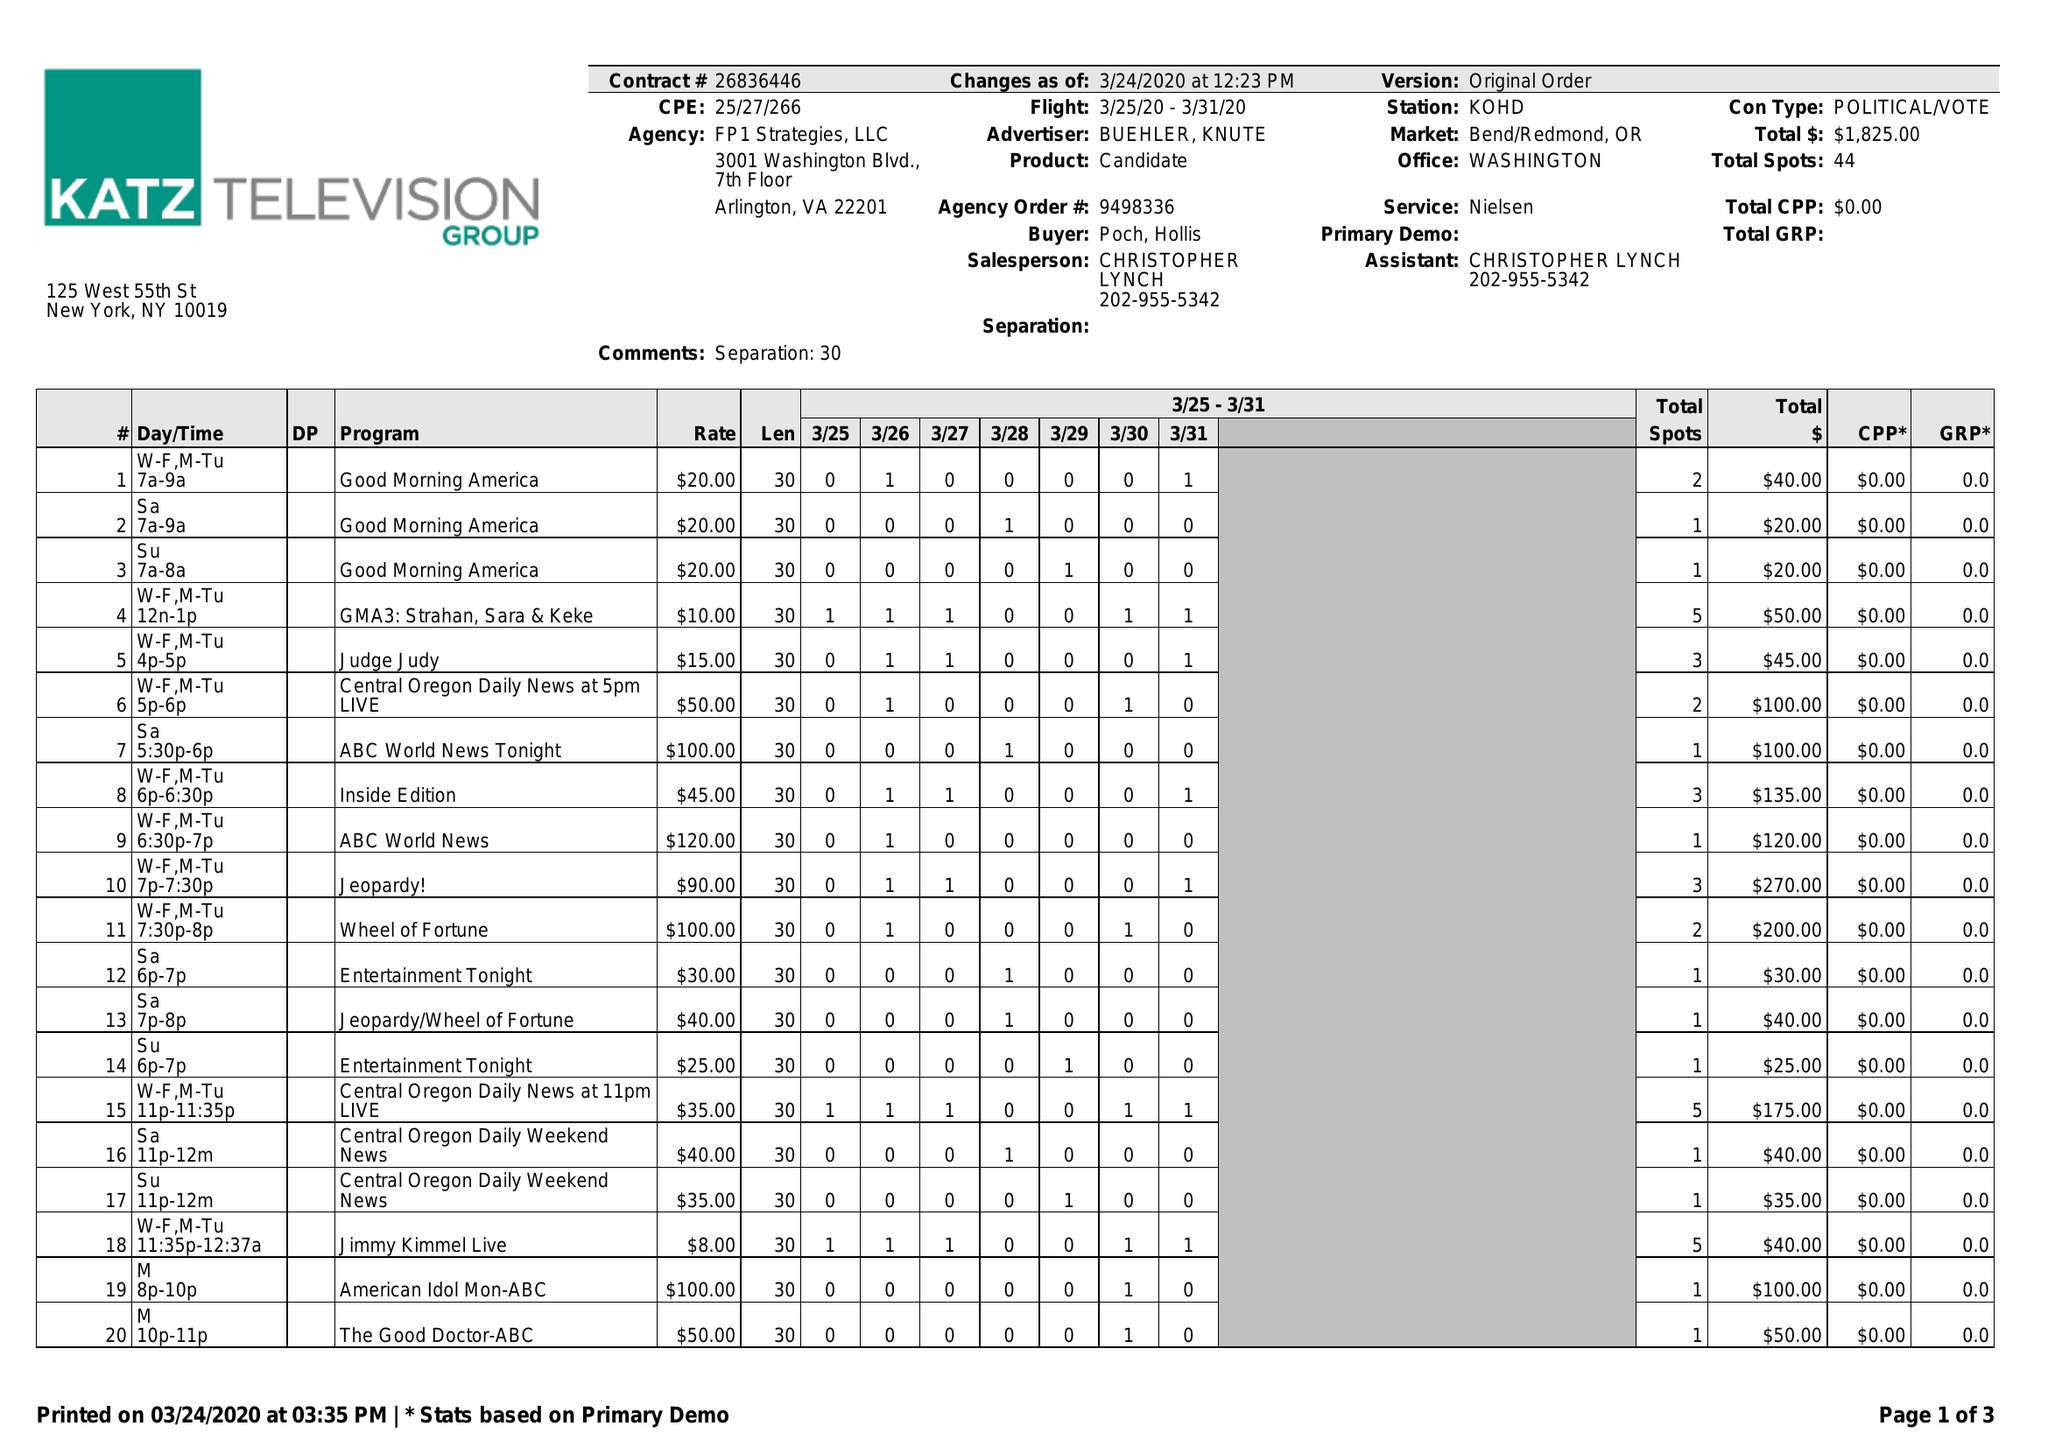What is the value for the gross_amount?
Answer the question using a single word or phrase. 1825.00 